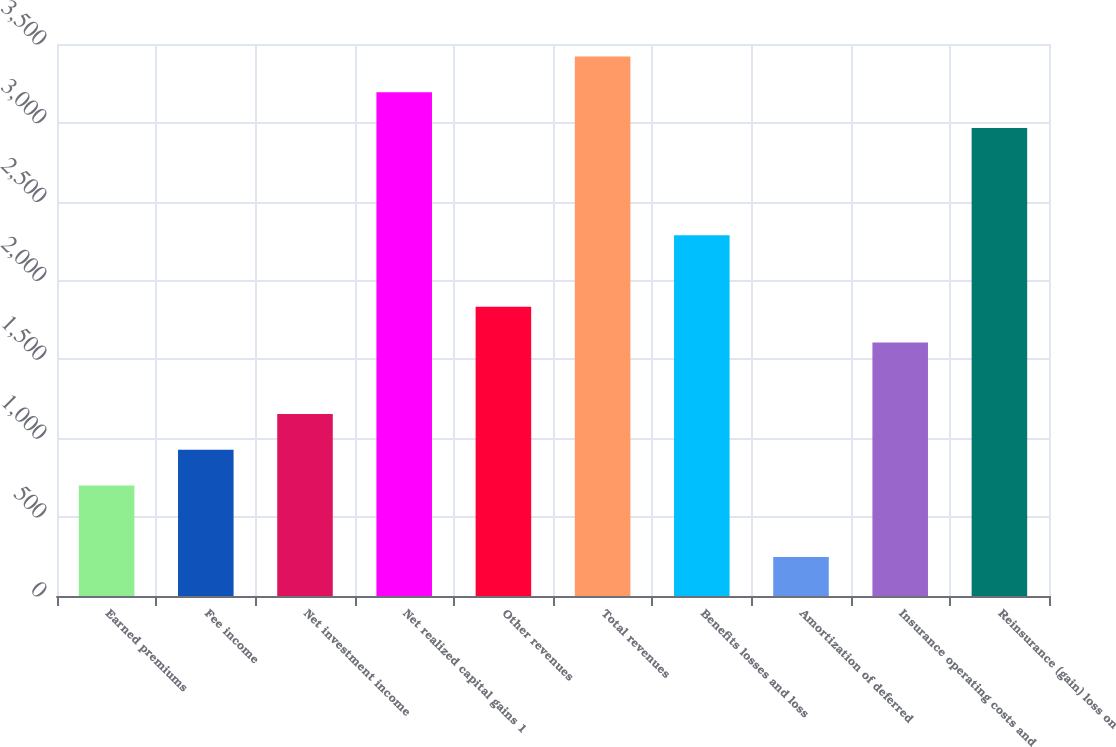<chart> <loc_0><loc_0><loc_500><loc_500><bar_chart><fcel>Earned premiums<fcel>Fee income<fcel>Net investment income<fcel>Net realized capital gains 1<fcel>Other revenues<fcel>Total revenues<fcel>Benefits losses and loss<fcel>Amortization of deferred<fcel>Insurance operating costs and<fcel>Reinsurance (gain) loss on<nl><fcel>700.8<fcel>927.4<fcel>1154<fcel>3193.4<fcel>1833.8<fcel>3420<fcel>2287<fcel>247.6<fcel>1607.2<fcel>2966.8<nl></chart> 